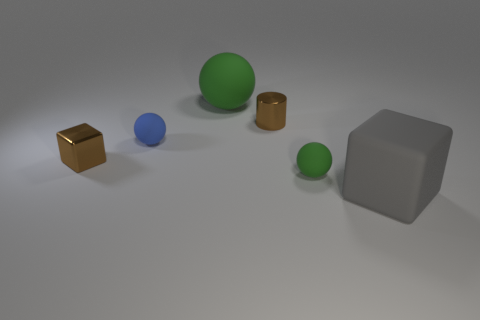Add 3 brown metal cylinders. How many objects exist? 9 Subtract all cylinders. How many objects are left? 5 Subtract 1 brown cylinders. How many objects are left? 5 Subtract all large cubes. Subtract all tiny blue balls. How many objects are left? 4 Add 6 big rubber blocks. How many big rubber blocks are left? 7 Add 6 big things. How many big things exist? 8 